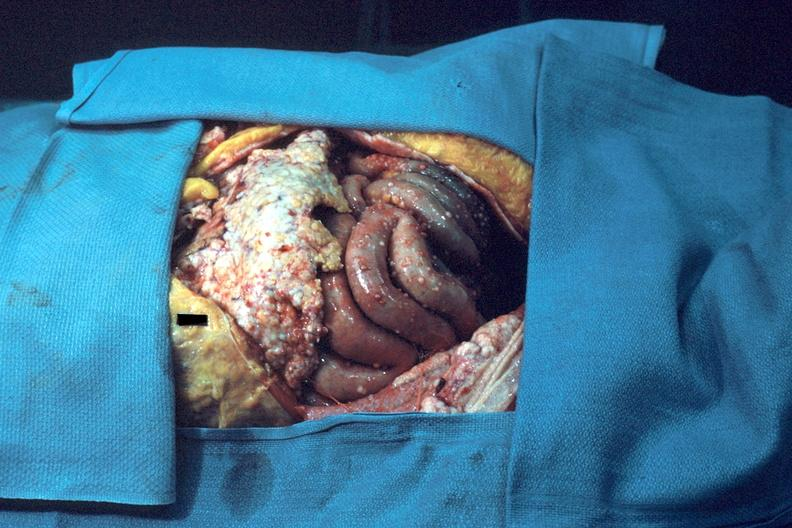does an opened peritoneal cavity cause by fibrous band strangulation show opened abdominal cavity show typical carcinomatosis?
Answer the question using a single word or phrase. No 